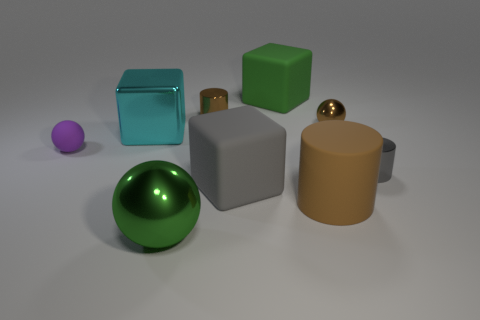Add 1 blocks. How many objects exist? 10 Subtract all cylinders. How many objects are left? 6 Add 9 red shiny cubes. How many red shiny cubes exist? 9 Subtract 1 green cubes. How many objects are left? 8 Subtract all green matte cubes. Subtract all gray shiny cylinders. How many objects are left? 7 Add 7 cyan metal blocks. How many cyan metal blocks are left? 8 